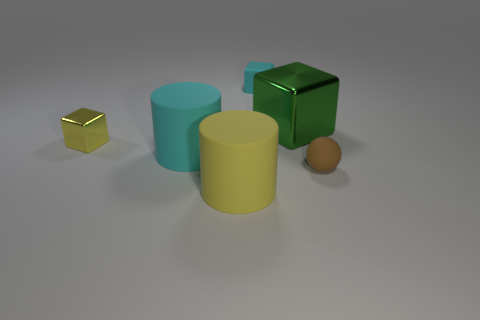What size is the cyan matte object that is the same shape as the green thing?
Provide a succinct answer. Small. What is the size of the thing that is both in front of the large metallic cube and right of the large yellow cylinder?
Give a very brief answer. Small. Does the brown object have the same shape as the matte thing behind the tiny yellow block?
Ensure brevity in your answer.  No. How many objects are rubber cylinders that are to the left of the small cyan cube or tiny yellow metal blocks?
Give a very brief answer. 3. Do the large yellow thing and the cyan thing that is behind the cyan rubber cylinder have the same material?
Ensure brevity in your answer.  Yes. There is a tiny thing in front of the small object that is on the left side of the small rubber block; what is its shape?
Ensure brevity in your answer.  Sphere. Does the big metal thing have the same color as the tiny cube that is in front of the rubber cube?
Provide a short and direct response. No. Is there any other thing that is made of the same material as the big yellow thing?
Your answer should be very brief. Yes. The big yellow object has what shape?
Keep it short and to the point. Cylinder. There is a metallic object behind the yellow object that is to the left of the big yellow cylinder; what size is it?
Keep it short and to the point. Large. 